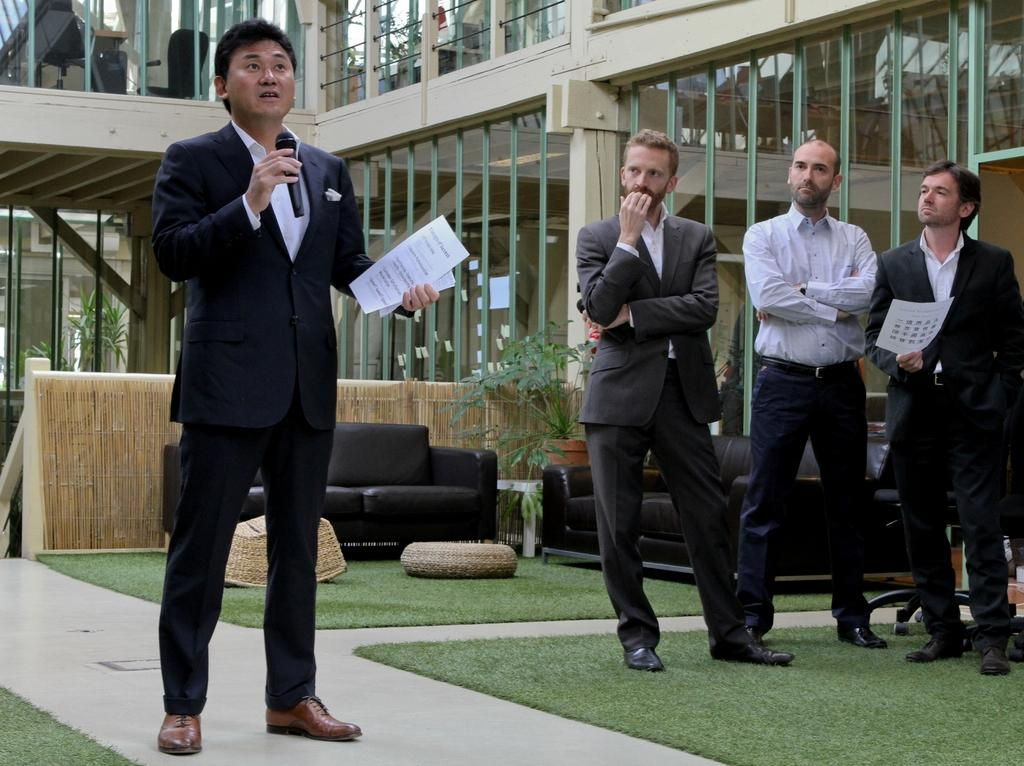What can be seen on the right side of the image? There are people standing at the right side of the image. What is the man doing at the left side of the image? The man is holding a microphone. What type of furniture is present in the image? There are black color sofas in the image. Can you tell me how many buttons are on the man's shirt in the image? There is no information about the man's shirt or buttons in the image, so it cannot be determined. Is the man's father present in the image? There is no information about the man's father or any other family members in the image, so it cannot be determined. 